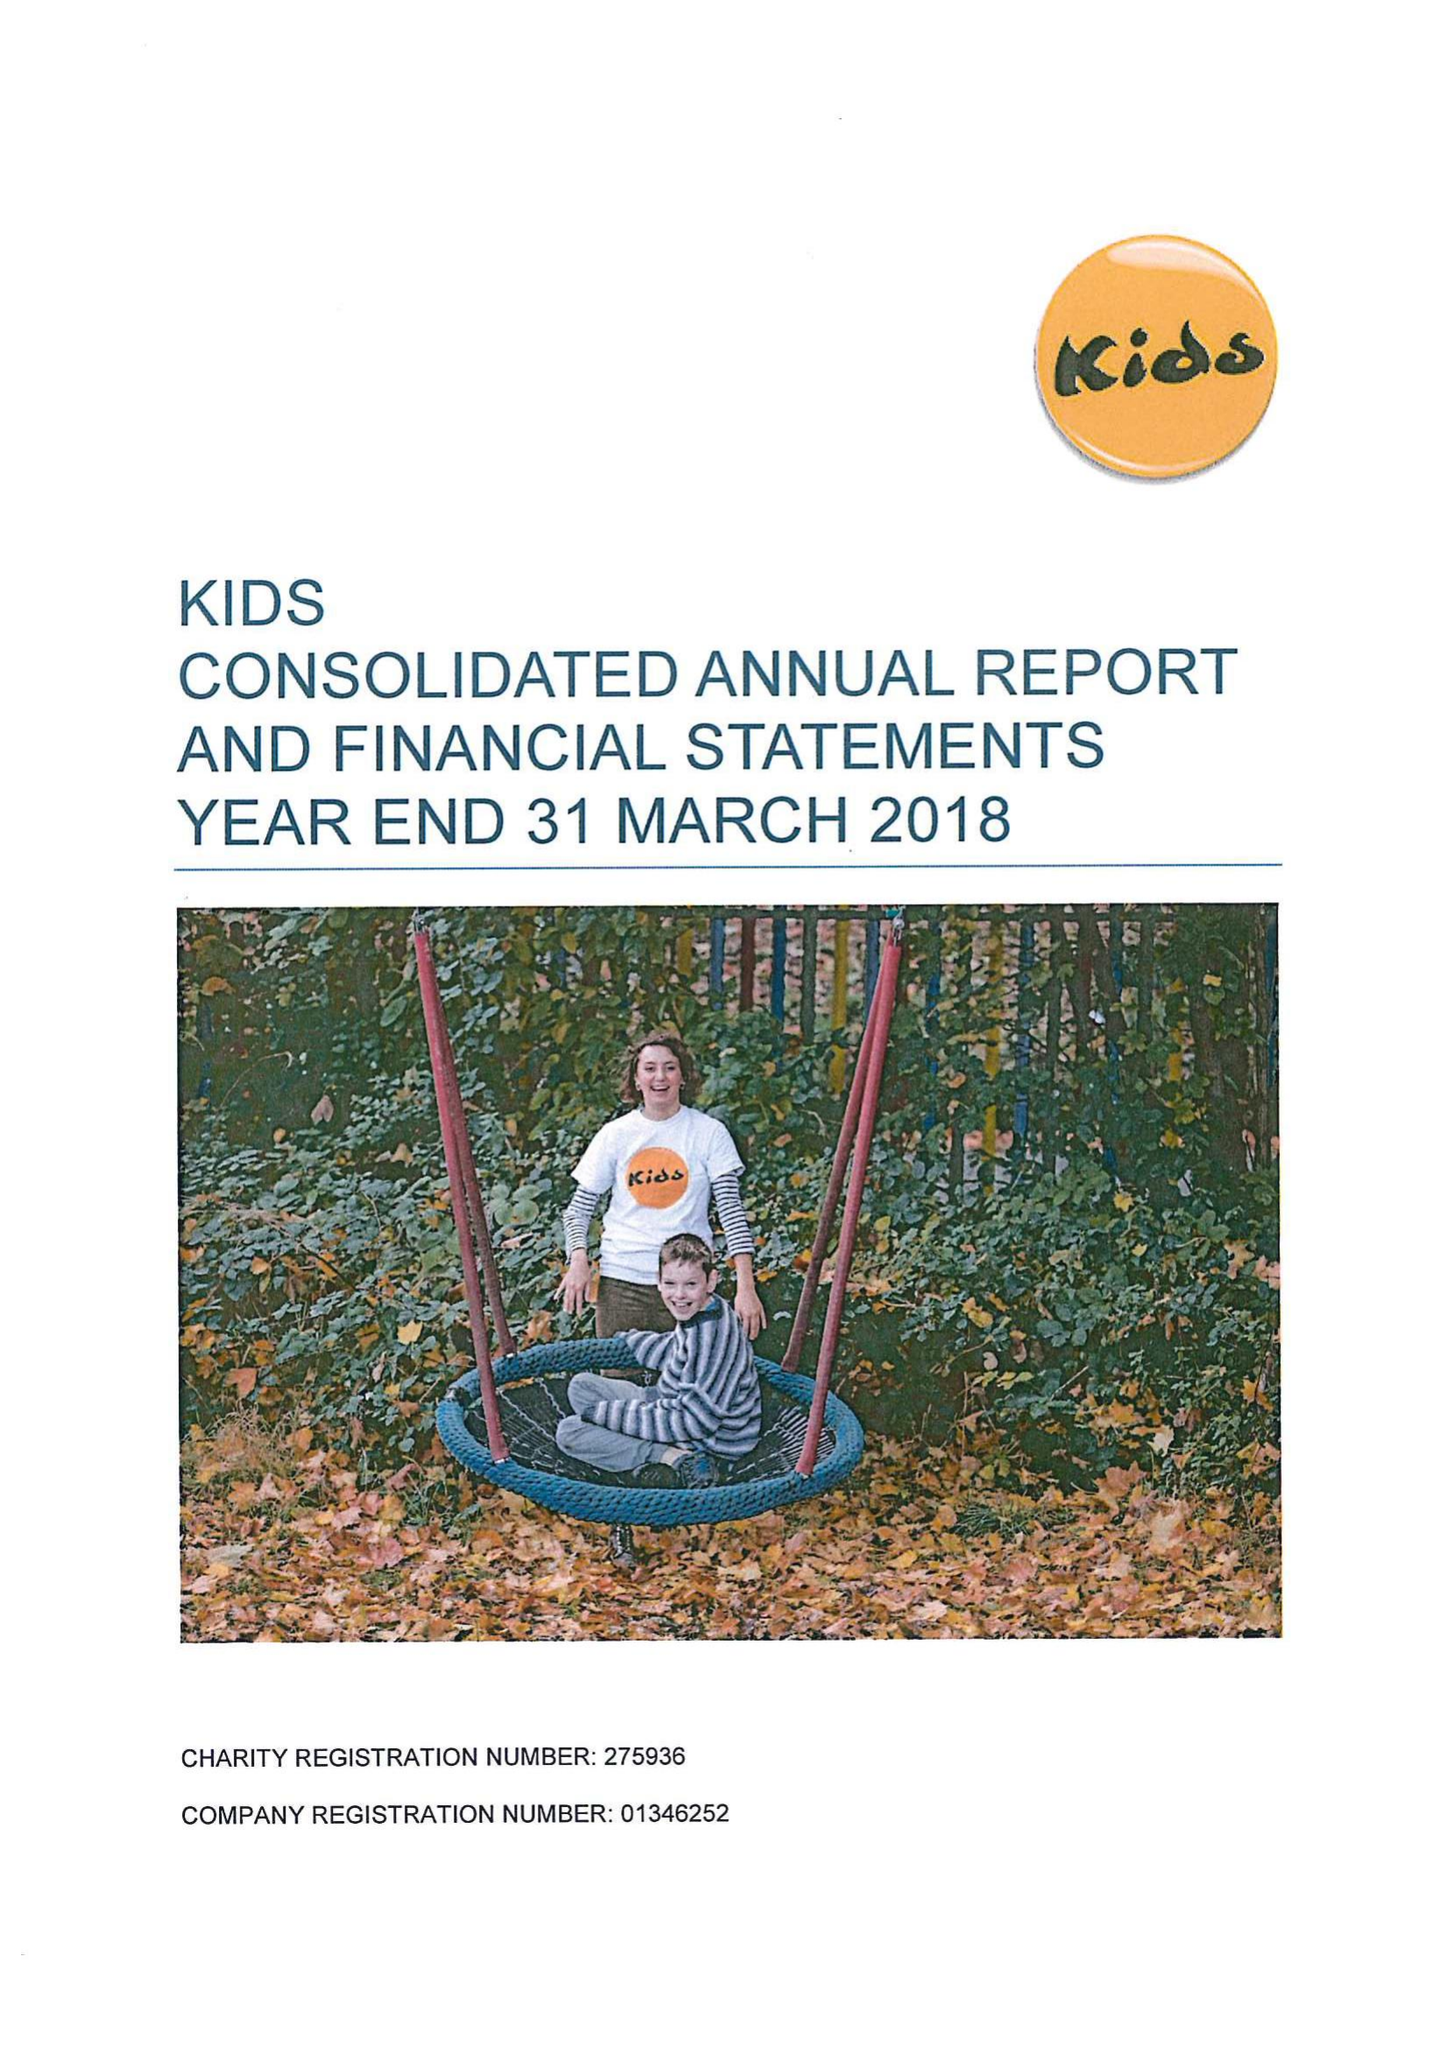What is the value for the address__street_line?
Answer the question using a single word or phrase. 7-9 ELLIOTT'S PLACE 